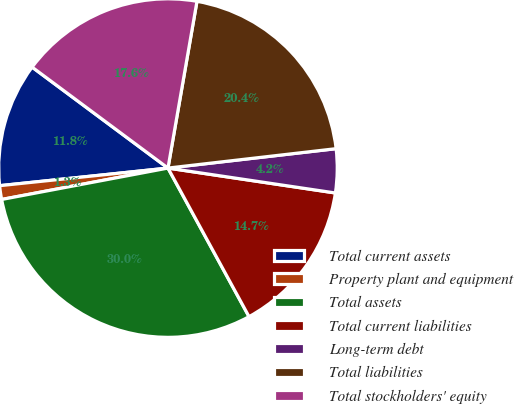Convert chart. <chart><loc_0><loc_0><loc_500><loc_500><pie_chart><fcel>Total current assets<fcel>Property plant and equipment<fcel>Total assets<fcel>Total current liabilities<fcel>Long-term debt<fcel>Total liabilities<fcel>Total stockholders' equity<nl><fcel>11.83%<fcel>1.31%<fcel>29.98%<fcel>14.7%<fcel>4.18%<fcel>20.43%<fcel>17.57%<nl></chart> 